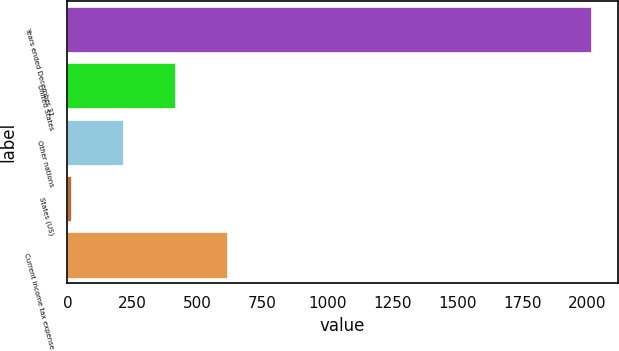<chart> <loc_0><loc_0><loc_500><loc_500><bar_chart><fcel>Years ended December 31<fcel>United States<fcel>Other nations<fcel>States (US)<fcel>Current income tax expense<nl><fcel>2015<fcel>413.4<fcel>213.2<fcel>13<fcel>613.6<nl></chart> 